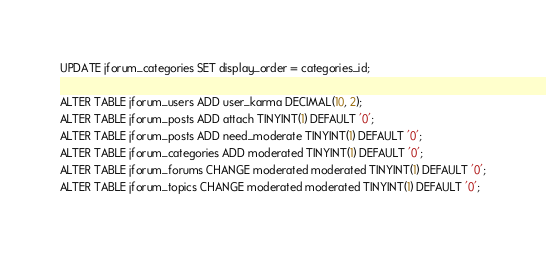Convert code to text. <code><loc_0><loc_0><loc_500><loc_500><_SQL_>UPDATE jforum_categories SET display_order = categories_id;

ALTER TABLE jforum_users ADD user_karma DECIMAL(10, 2);
ALTER TABLE jforum_posts ADD attach TINYINT(1) DEFAULT '0';
ALTER TABLE jforum_posts ADD need_moderate TINYINT(1) DEFAULT '0';
ALTER TABLE jforum_categories ADD moderated TINYINT(1) DEFAULT '0';
ALTER TABLE jforum_forums CHANGE moderated moderated TINYINT(1) DEFAULT '0';
ALTER TABLE jforum_topics CHANGE moderated moderated TINYINT(1) DEFAULT '0';</code> 